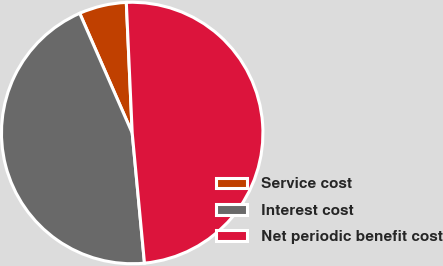Convert chart. <chart><loc_0><loc_0><loc_500><loc_500><pie_chart><fcel>Service cost<fcel>Interest cost<fcel>Net periodic benefit cost<nl><fcel>5.86%<fcel>44.92%<fcel>49.22%<nl></chart> 